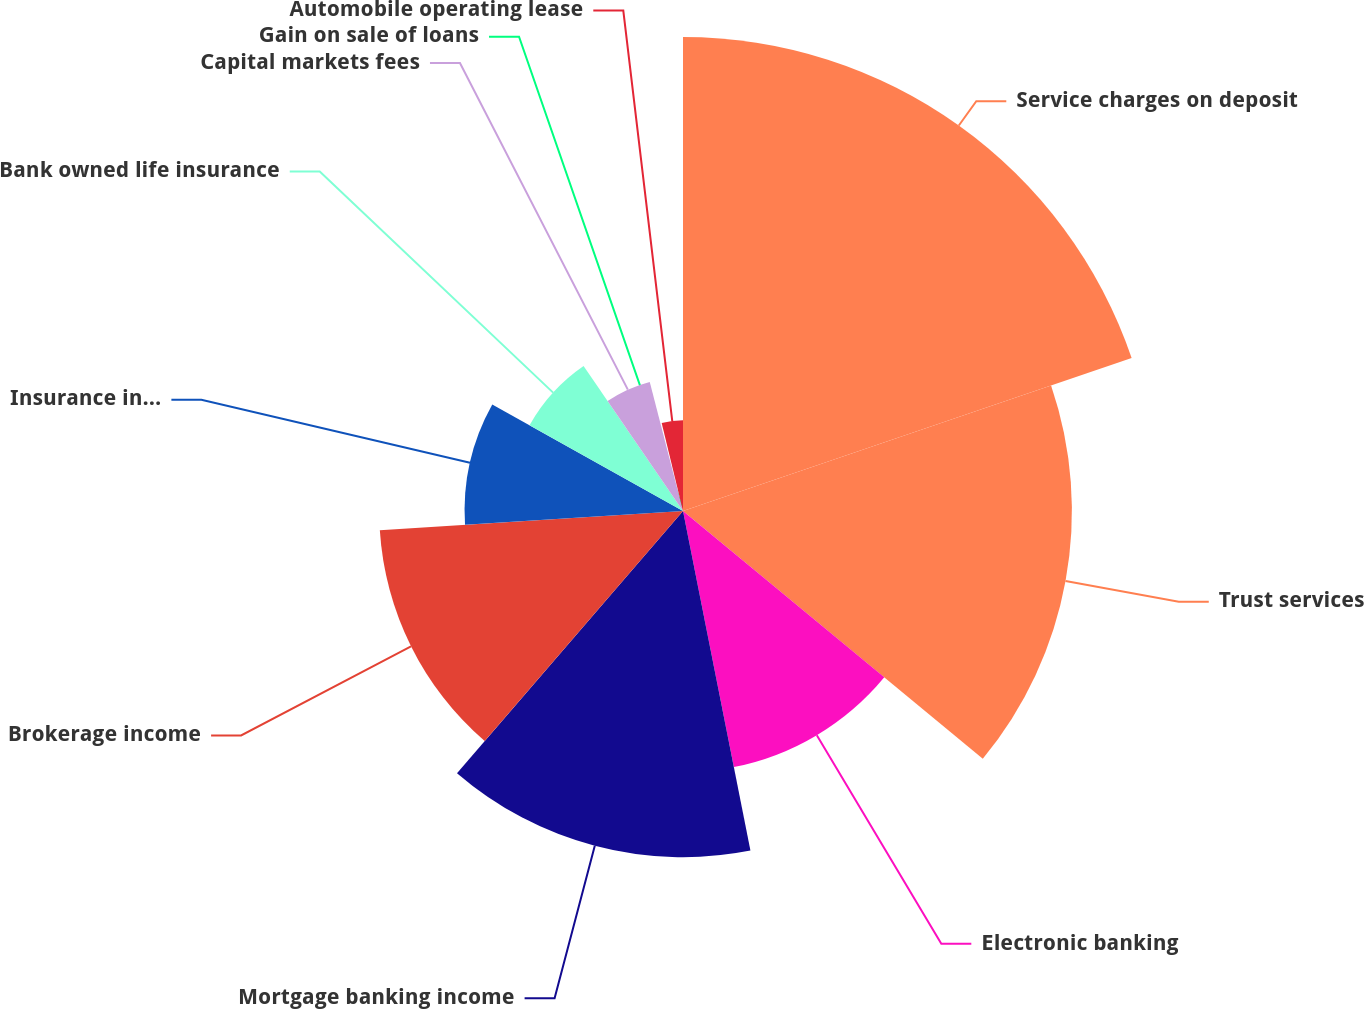Convert chart to OTSL. <chart><loc_0><loc_0><loc_500><loc_500><pie_chart><fcel>Service charges on deposit<fcel>Trust services<fcel>Electronic banking<fcel>Mortgage banking income<fcel>Brokerage income<fcel>Insurance income<fcel>Bank owned life insurance<fcel>Capital markets fees<fcel>Gain on sale of loans<fcel>Automobile operating lease<nl><fcel>19.77%<fcel>16.22%<fcel>10.89%<fcel>14.44%<fcel>12.67%<fcel>9.11%<fcel>7.33%<fcel>5.56%<fcel>0.23%<fcel>3.78%<nl></chart> 